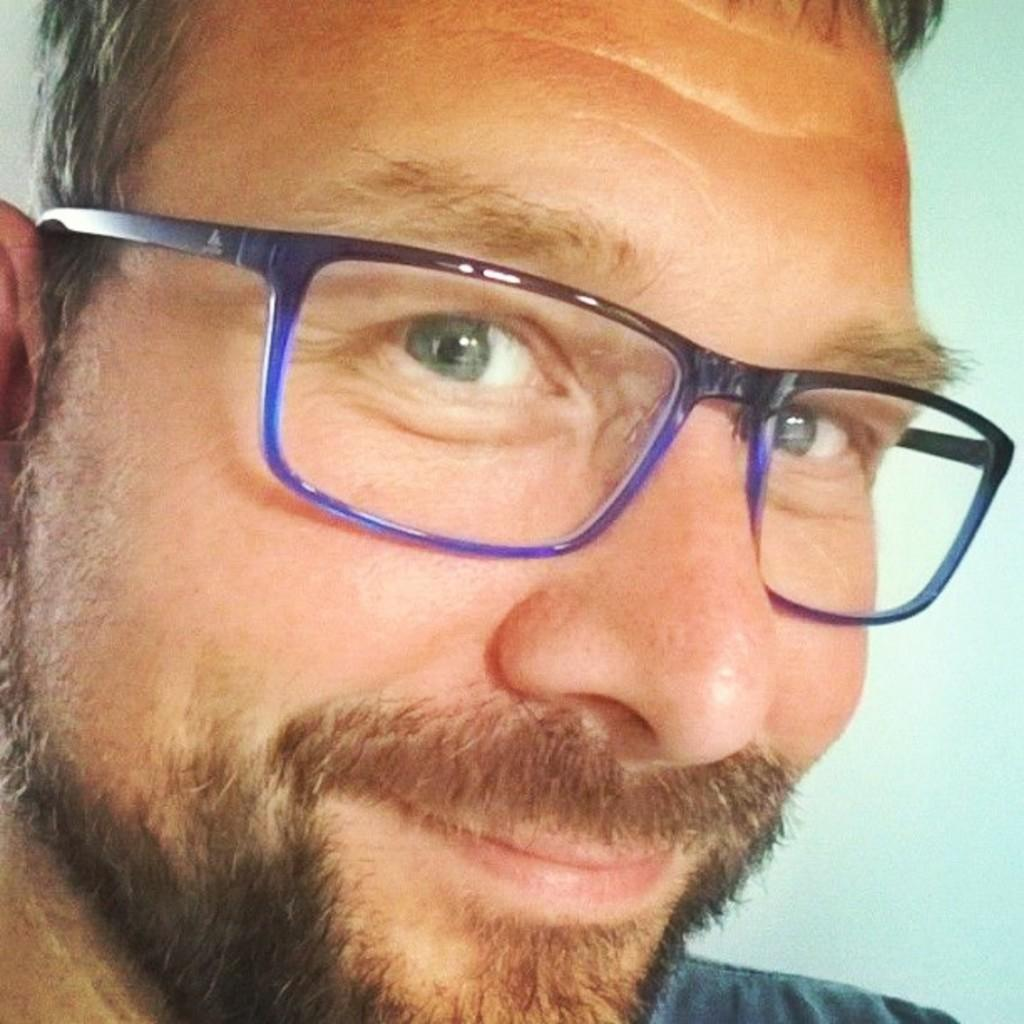What is present in the image? There is a person in the image. How much of the person is visible? Only the head of the person is visible. What accessory is the person wearing? The person is wearing spectacles. What type of reasoning does the person in the image use to solve a dime-related problem? There is no dime or problem-solving situation present in the image, as it only shows a person's head with spectacles. 